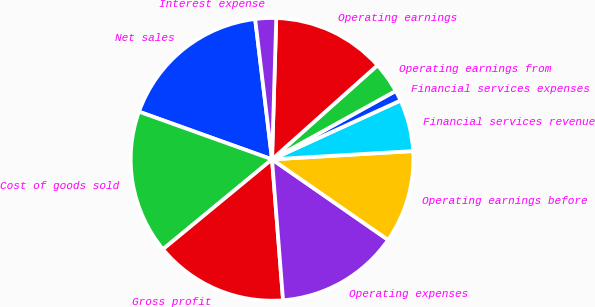Convert chart. <chart><loc_0><loc_0><loc_500><loc_500><pie_chart><fcel>Net sales<fcel>Cost of goods sold<fcel>Gross profit<fcel>Operating expenses<fcel>Operating earnings before<fcel>Financial services revenue<fcel>Financial services expenses<fcel>Operating earnings from<fcel>Operating earnings<fcel>Interest expense<nl><fcel>17.62%<fcel>16.45%<fcel>15.27%<fcel>14.1%<fcel>10.59%<fcel>5.9%<fcel>1.21%<fcel>3.55%<fcel>12.93%<fcel>2.38%<nl></chart> 